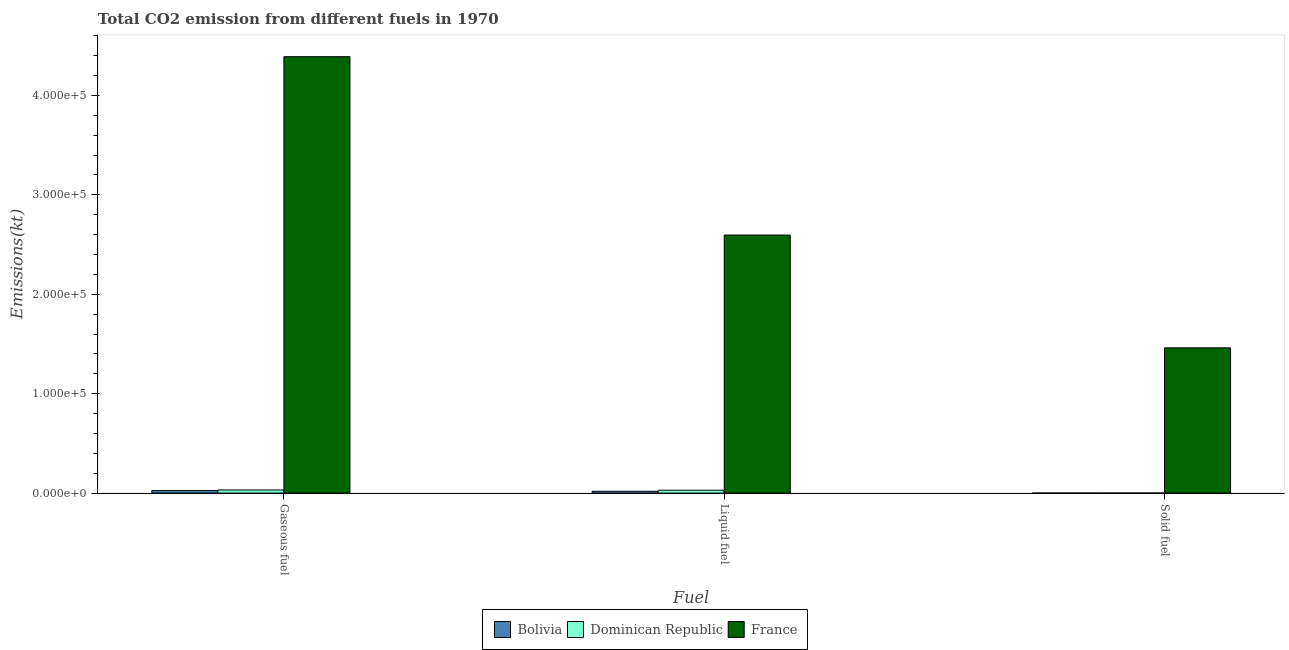How many bars are there on the 2nd tick from the right?
Ensure brevity in your answer.  3. What is the label of the 2nd group of bars from the left?
Your answer should be very brief. Liquid fuel. What is the amount of co2 emissions from liquid fuel in Bolivia?
Make the answer very short. 1811.5. Across all countries, what is the maximum amount of co2 emissions from gaseous fuel?
Give a very brief answer. 4.39e+05. Across all countries, what is the minimum amount of co2 emissions from liquid fuel?
Make the answer very short. 1811.5. What is the total amount of co2 emissions from solid fuel in the graph?
Your response must be concise. 1.46e+05. What is the difference between the amount of co2 emissions from solid fuel in Dominican Republic and that in Bolivia?
Your answer should be very brief. 0. What is the difference between the amount of co2 emissions from gaseous fuel in France and the amount of co2 emissions from solid fuel in Dominican Republic?
Your answer should be very brief. 4.39e+05. What is the average amount of co2 emissions from gaseous fuel per country?
Make the answer very short. 1.48e+05. What is the difference between the amount of co2 emissions from liquid fuel and amount of co2 emissions from solid fuel in France?
Ensure brevity in your answer.  1.13e+05. In how many countries, is the amount of co2 emissions from solid fuel greater than 80000 kt?
Your response must be concise. 1. What is the difference between the highest and the second highest amount of co2 emissions from solid fuel?
Give a very brief answer. 1.46e+05. What is the difference between the highest and the lowest amount of co2 emissions from liquid fuel?
Your answer should be compact. 2.58e+05. In how many countries, is the amount of co2 emissions from gaseous fuel greater than the average amount of co2 emissions from gaseous fuel taken over all countries?
Give a very brief answer. 1. What does the 2nd bar from the left in Liquid fuel represents?
Your response must be concise. Dominican Republic. What does the 2nd bar from the right in Gaseous fuel represents?
Keep it short and to the point. Dominican Republic. Are all the bars in the graph horizontal?
Offer a terse response. No. Are the values on the major ticks of Y-axis written in scientific E-notation?
Offer a terse response. Yes. Does the graph contain grids?
Make the answer very short. No. Where does the legend appear in the graph?
Make the answer very short. Bottom center. How many legend labels are there?
Offer a very short reply. 3. What is the title of the graph?
Your response must be concise. Total CO2 emission from different fuels in 1970. Does "Netherlands" appear as one of the legend labels in the graph?
Offer a very short reply. No. What is the label or title of the X-axis?
Your response must be concise. Fuel. What is the label or title of the Y-axis?
Offer a very short reply. Emissions(kt). What is the Emissions(kt) in Bolivia in Gaseous fuel?
Offer a very short reply. 2486.23. What is the Emissions(kt) in Dominican Republic in Gaseous fuel?
Your response must be concise. 3109.62. What is the Emissions(kt) in France in Gaseous fuel?
Provide a short and direct response. 4.39e+05. What is the Emissions(kt) of Bolivia in Liquid fuel?
Ensure brevity in your answer.  1811.5. What is the Emissions(kt) in Dominican Republic in Liquid fuel?
Give a very brief answer. 2860.26. What is the Emissions(kt) in France in Liquid fuel?
Keep it short and to the point. 2.60e+05. What is the Emissions(kt) of Bolivia in Solid fuel?
Provide a short and direct response. 3.67. What is the Emissions(kt) of Dominican Republic in Solid fuel?
Provide a succinct answer. 3.67. What is the Emissions(kt) in France in Solid fuel?
Make the answer very short. 1.46e+05. Across all Fuel, what is the maximum Emissions(kt) in Bolivia?
Give a very brief answer. 2486.23. Across all Fuel, what is the maximum Emissions(kt) in Dominican Republic?
Offer a terse response. 3109.62. Across all Fuel, what is the maximum Emissions(kt) in France?
Your answer should be very brief. 4.39e+05. Across all Fuel, what is the minimum Emissions(kt) of Bolivia?
Ensure brevity in your answer.  3.67. Across all Fuel, what is the minimum Emissions(kt) of Dominican Republic?
Offer a very short reply. 3.67. Across all Fuel, what is the minimum Emissions(kt) in France?
Ensure brevity in your answer.  1.46e+05. What is the total Emissions(kt) in Bolivia in the graph?
Provide a short and direct response. 4301.39. What is the total Emissions(kt) of Dominican Republic in the graph?
Your answer should be very brief. 5973.54. What is the total Emissions(kt) of France in the graph?
Offer a very short reply. 8.45e+05. What is the difference between the Emissions(kt) of Bolivia in Gaseous fuel and that in Liquid fuel?
Offer a very short reply. 674.73. What is the difference between the Emissions(kt) in Dominican Republic in Gaseous fuel and that in Liquid fuel?
Offer a very short reply. 249.36. What is the difference between the Emissions(kt) in France in Gaseous fuel and that in Liquid fuel?
Provide a short and direct response. 1.79e+05. What is the difference between the Emissions(kt) of Bolivia in Gaseous fuel and that in Solid fuel?
Make the answer very short. 2482.56. What is the difference between the Emissions(kt) in Dominican Republic in Gaseous fuel and that in Solid fuel?
Offer a terse response. 3105.95. What is the difference between the Emissions(kt) in France in Gaseous fuel and that in Solid fuel?
Offer a very short reply. 2.93e+05. What is the difference between the Emissions(kt) in Bolivia in Liquid fuel and that in Solid fuel?
Give a very brief answer. 1807.83. What is the difference between the Emissions(kt) in Dominican Republic in Liquid fuel and that in Solid fuel?
Ensure brevity in your answer.  2856.59. What is the difference between the Emissions(kt) of France in Liquid fuel and that in Solid fuel?
Your answer should be compact. 1.13e+05. What is the difference between the Emissions(kt) of Bolivia in Gaseous fuel and the Emissions(kt) of Dominican Republic in Liquid fuel?
Provide a succinct answer. -374.03. What is the difference between the Emissions(kt) in Bolivia in Gaseous fuel and the Emissions(kt) in France in Liquid fuel?
Make the answer very short. -2.57e+05. What is the difference between the Emissions(kt) in Dominican Republic in Gaseous fuel and the Emissions(kt) in France in Liquid fuel?
Offer a very short reply. -2.56e+05. What is the difference between the Emissions(kt) of Bolivia in Gaseous fuel and the Emissions(kt) of Dominican Republic in Solid fuel?
Offer a terse response. 2482.56. What is the difference between the Emissions(kt) in Bolivia in Gaseous fuel and the Emissions(kt) in France in Solid fuel?
Keep it short and to the point. -1.44e+05. What is the difference between the Emissions(kt) in Dominican Republic in Gaseous fuel and the Emissions(kt) in France in Solid fuel?
Offer a very short reply. -1.43e+05. What is the difference between the Emissions(kt) of Bolivia in Liquid fuel and the Emissions(kt) of Dominican Republic in Solid fuel?
Keep it short and to the point. 1807.83. What is the difference between the Emissions(kt) in Bolivia in Liquid fuel and the Emissions(kt) in France in Solid fuel?
Make the answer very short. -1.44e+05. What is the difference between the Emissions(kt) of Dominican Republic in Liquid fuel and the Emissions(kt) of France in Solid fuel?
Your answer should be very brief. -1.43e+05. What is the average Emissions(kt) in Bolivia per Fuel?
Offer a very short reply. 1433.8. What is the average Emissions(kt) in Dominican Republic per Fuel?
Provide a succinct answer. 1991.18. What is the average Emissions(kt) in France per Fuel?
Provide a short and direct response. 2.82e+05. What is the difference between the Emissions(kt) in Bolivia and Emissions(kt) in Dominican Republic in Gaseous fuel?
Your answer should be compact. -623.39. What is the difference between the Emissions(kt) in Bolivia and Emissions(kt) in France in Gaseous fuel?
Your answer should be very brief. -4.37e+05. What is the difference between the Emissions(kt) in Dominican Republic and Emissions(kt) in France in Gaseous fuel?
Provide a short and direct response. -4.36e+05. What is the difference between the Emissions(kt) of Bolivia and Emissions(kt) of Dominican Republic in Liquid fuel?
Provide a short and direct response. -1048.76. What is the difference between the Emissions(kt) of Bolivia and Emissions(kt) of France in Liquid fuel?
Your answer should be very brief. -2.58e+05. What is the difference between the Emissions(kt) of Dominican Republic and Emissions(kt) of France in Liquid fuel?
Offer a very short reply. -2.57e+05. What is the difference between the Emissions(kt) of Bolivia and Emissions(kt) of France in Solid fuel?
Provide a short and direct response. -1.46e+05. What is the difference between the Emissions(kt) of Dominican Republic and Emissions(kt) of France in Solid fuel?
Provide a succinct answer. -1.46e+05. What is the ratio of the Emissions(kt) in Bolivia in Gaseous fuel to that in Liquid fuel?
Provide a short and direct response. 1.37. What is the ratio of the Emissions(kt) of Dominican Republic in Gaseous fuel to that in Liquid fuel?
Offer a very short reply. 1.09. What is the ratio of the Emissions(kt) of France in Gaseous fuel to that in Liquid fuel?
Offer a terse response. 1.69. What is the ratio of the Emissions(kt) in Bolivia in Gaseous fuel to that in Solid fuel?
Provide a succinct answer. 678. What is the ratio of the Emissions(kt) of Dominican Republic in Gaseous fuel to that in Solid fuel?
Make the answer very short. 848. What is the ratio of the Emissions(kt) in France in Gaseous fuel to that in Solid fuel?
Give a very brief answer. 3. What is the ratio of the Emissions(kt) of Bolivia in Liquid fuel to that in Solid fuel?
Make the answer very short. 494. What is the ratio of the Emissions(kt) in Dominican Republic in Liquid fuel to that in Solid fuel?
Provide a short and direct response. 780. What is the ratio of the Emissions(kt) in France in Liquid fuel to that in Solid fuel?
Your response must be concise. 1.78. What is the difference between the highest and the second highest Emissions(kt) of Bolivia?
Offer a very short reply. 674.73. What is the difference between the highest and the second highest Emissions(kt) of Dominican Republic?
Offer a terse response. 249.36. What is the difference between the highest and the second highest Emissions(kt) of France?
Your answer should be very brief. 1.79e+05. What is the difference between the highest and the lowest Emissions(kt) of Bolivia?
Your answer should be very brief. 2482.56. What is the difference between the highest and the lowest Emissions(kt) in Dominican Republic?
Ensure brevity in your answer.  3105.95. What is the difference between the highest and the lowest Emissions(kt) of France?
Offer a terse response. 2.93e+05. 